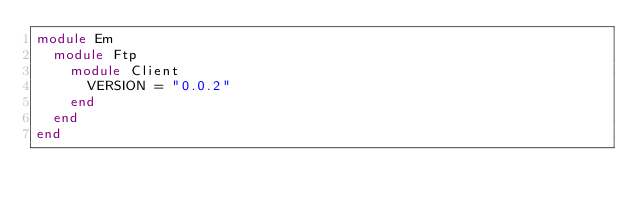Convert code to text. <code><loc_0><loc_0><loc_500><loc_500><_Ruby_>module Em
  module Ftp
    module Client
      VERSION = "0.0.2"
    end
  end
end
</code> 